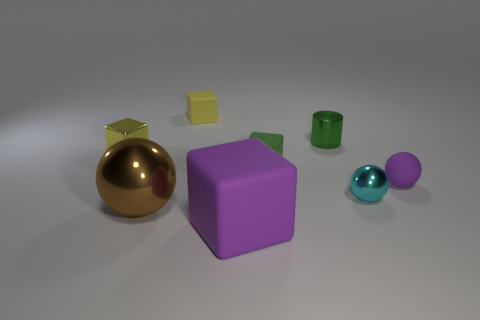Does the purple object that is on the right side of the green cylinder have the same size as the tiny yellow metallic block?
Your answer should be very brief. Yes. Is the number of big brown metallic balls right of the rubber ball greater than the number of big brown objects?
Keep it short and to the point. No. How many tiny yellow shiny blocks are to the left of the tiny rubber block that is in front of the green cylinder?
Your answer should be compact. 1. Are there fewer large blocks in front of the purple matte cube than green shiny things?
Keep it short and to the point. Yes. There is a yellow block on the right side of the tiny yellow thing that is to the left of the brown metal thing; is there a yellow metal block to the left of it?
Ensure brevity in your answer.  Yes. Is the small purple thing made of the same material as the green object that is behind the yellow metal cube?
Offer a terse response. No. There is a rubber thing in front of the metallic sphere that is to the right of the large purple matte cube; what is its color?
Your answer should be compact. Purple. Is there a small cube that has the same color as the tiny metal cylinder?
Your answer should be compact. Yes. What size is the metal ball left of the matte object that is left of the matte object in front of the tiny purple rubber thing?
Your response must be concise. Large. There is a big purple thing; is its shape the same as the green object in front of the cylinder?
Offer a very short reply. Yes. 